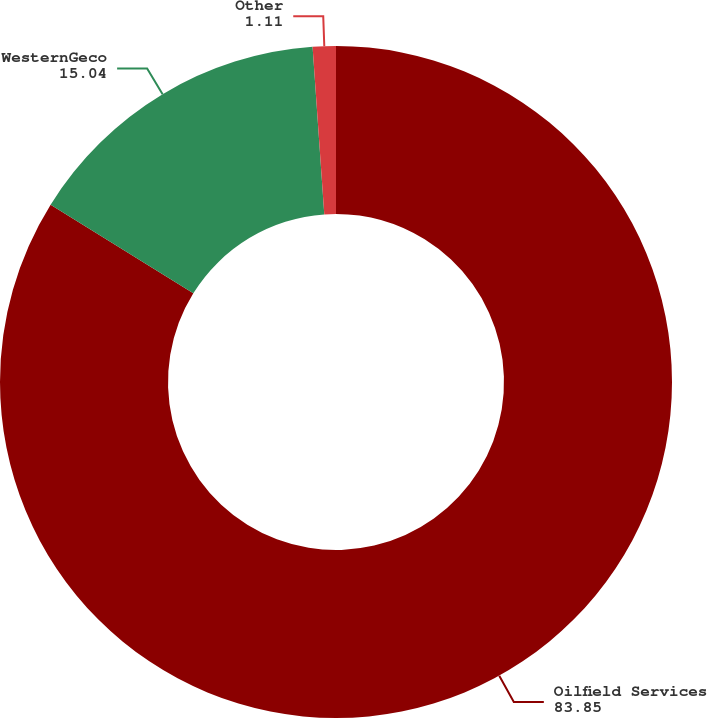<chart> <loc_0><loc_0><loc_500><loc_500><pie_chart><fcel>Oilfield Services<fcel>WesternGeco<fcel>Other<nl><fcel>83.85%<fcel>15.04%<fcel>1.11%<nl></chart> 